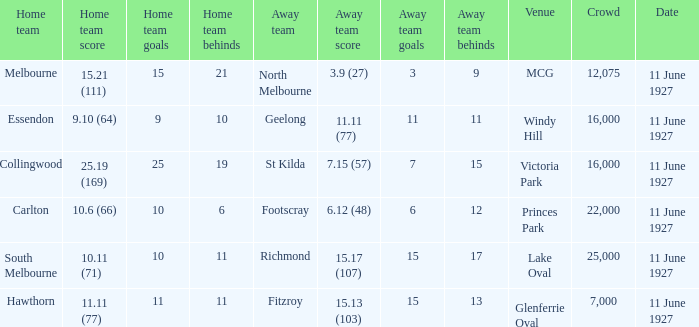How many people were in the crowd when Essendon was the home team? 1.0. 